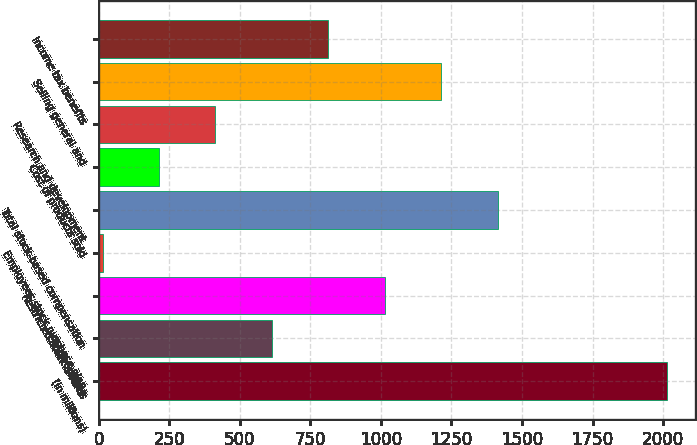<chart> <loc_0><loc_0><loc_500><loc_500><bar_chart><fcel>(in millions)<fcel>Stock options<fcel>Restricted stock awards<fcel>Employees stock purchase plan<fcel>Total stock-based compensation<fcel>Cost of products sold<fcel>Research and development<fcel>Selling general and<fcel>Income tax benefits<nl><fcel>2014<fcel>613.3<fcel>1013.5<fcel>13<fcel>1413.7<fcel>213.1<fcel>413.2<fcel>1213.6<fcel>813.4<nl></chart> 